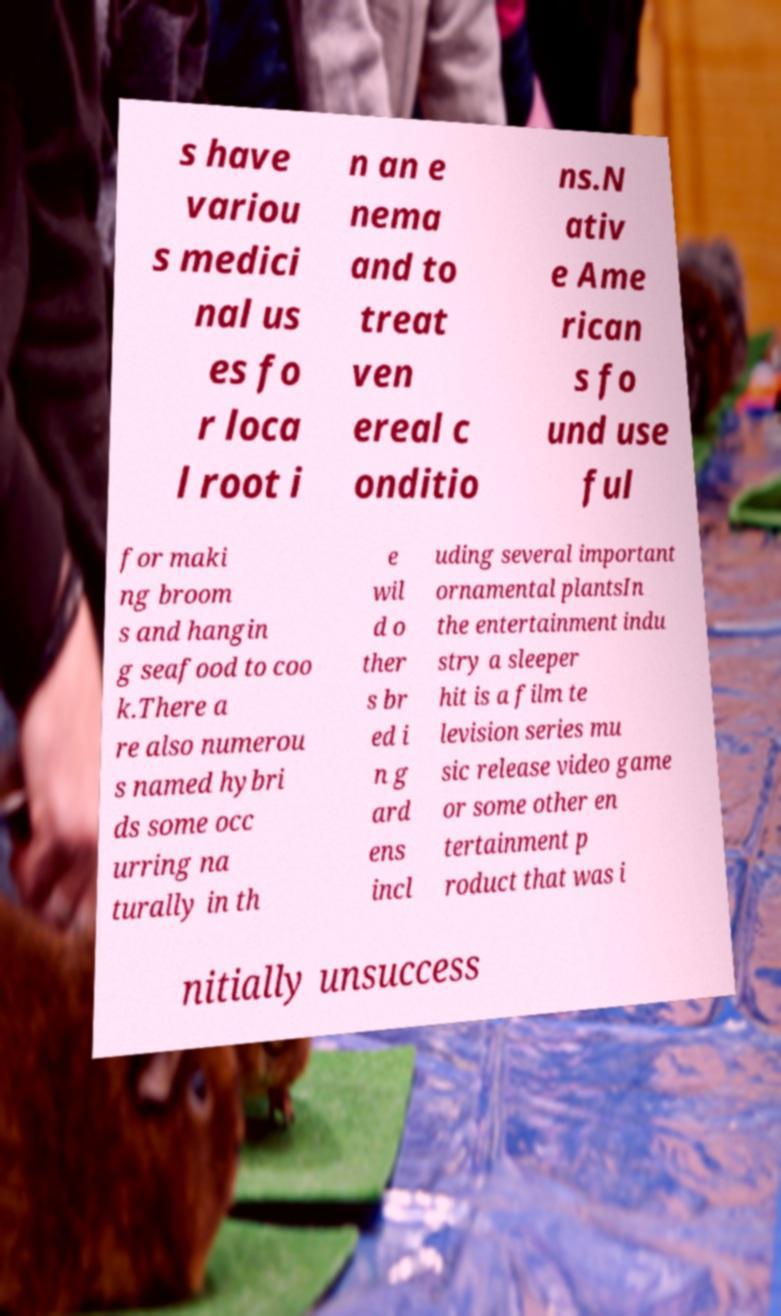Can you accurately transcribe the text from the provided image for me? s have variou s medici nal us es fo r loca l root i n an e nema and to treat ven ereal c onditio ns.N ativ e Ame rican s fo und use ful for maki ng broom s and hangin g seafood to coo k.There a re also numerou s named hybri ds some occ urring na turally in th e wil d o ther s br ed i n g ard ens incl uding several important ornamental plantsIn the entertainment indu stry a sleeper hit is a film te levision series mu sic release video game or some other en tertainment p roduct that was i nitially unsuccess 